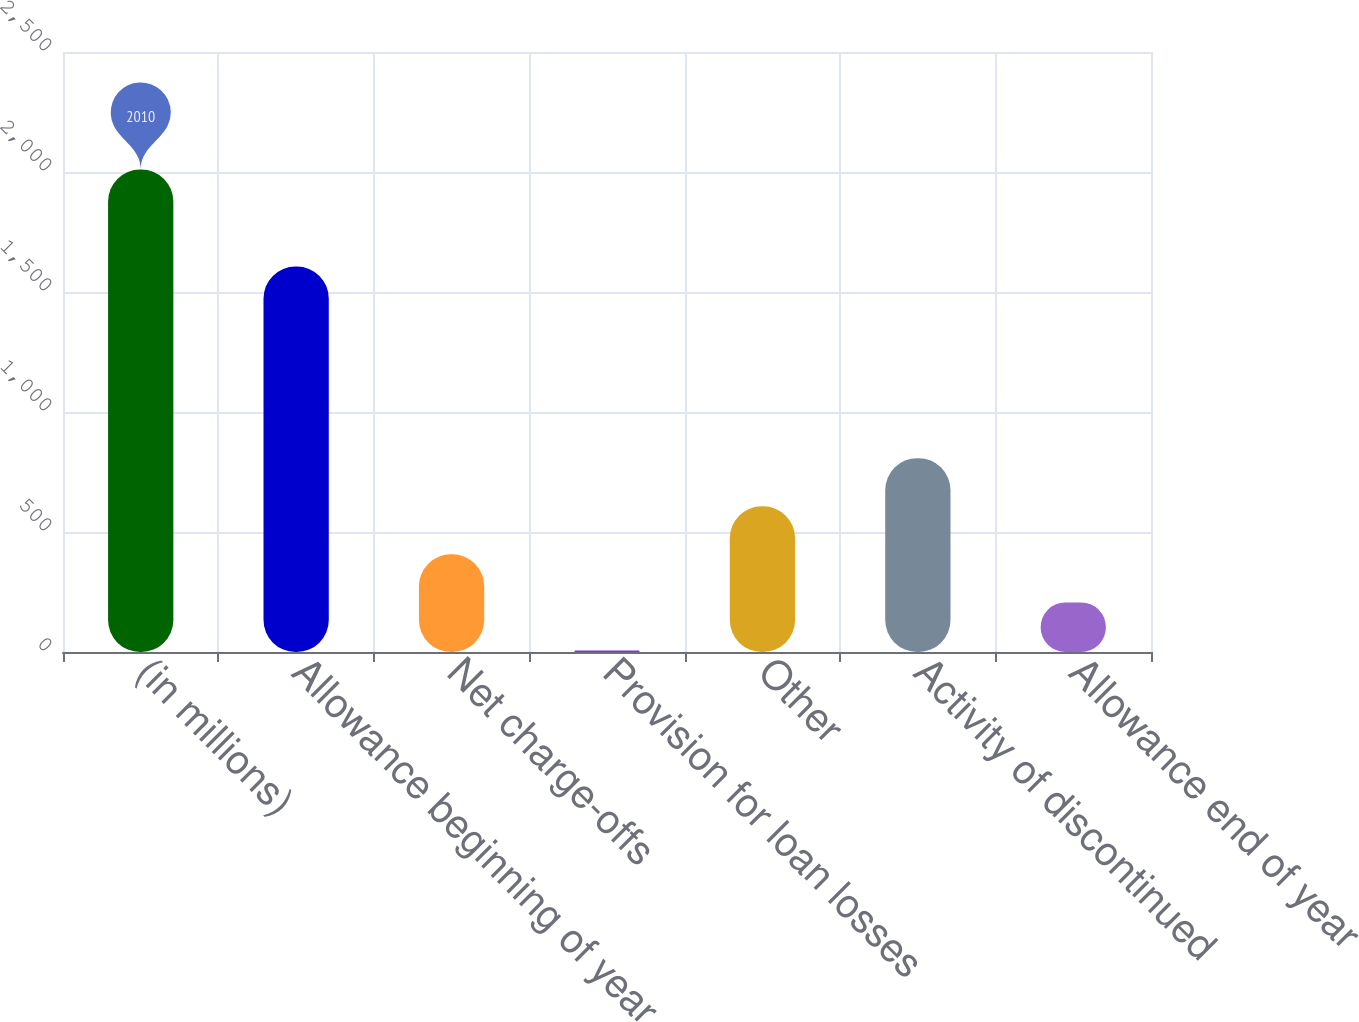Convert chart to OTSL. <chart><loc_0><loc_0><loc_500><loc_500><bar_chart><fcel>(in millions)<fcel>Allowance beginning of year<fcel>Net charge-offs<fcel>Provision for loan losses<fcel>Other<fcel>Activity of discontinued<fcel>Allowance end of year<nl><fcel>2010<fcel>1606<fcel>406.8<fcel>6<fcel>607.2<fcel>807.6<fcel>206.4<nl></chart> 